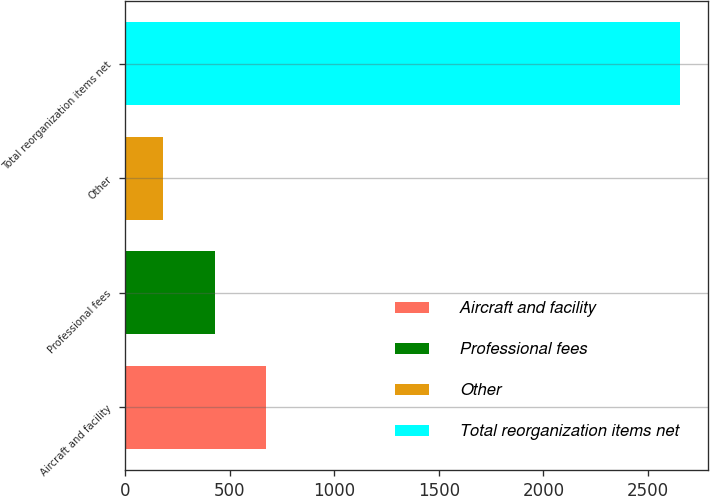<chart> <loc_0><loc_0><loc_500><loc_500><bar_chart><fcel>Aircraft and facility<fcel>Professional fees<fcel>Other<fcel>Total reorganization items net<nl><fcel>675<fcel>427.5<fcel>180<fcel>2655<nl></chart> 